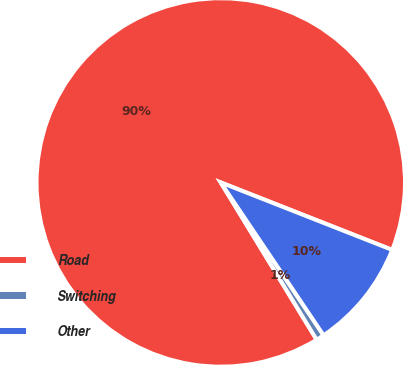Convert chart. <chart><loc_0><loc_0><loc_500><loc_500><pie_chart><fcel>Road<fcel>Switching<fcel>Other<nl><fcel>89.68%<fcel>0.71%<fcel>9.61%<nl></chart> 